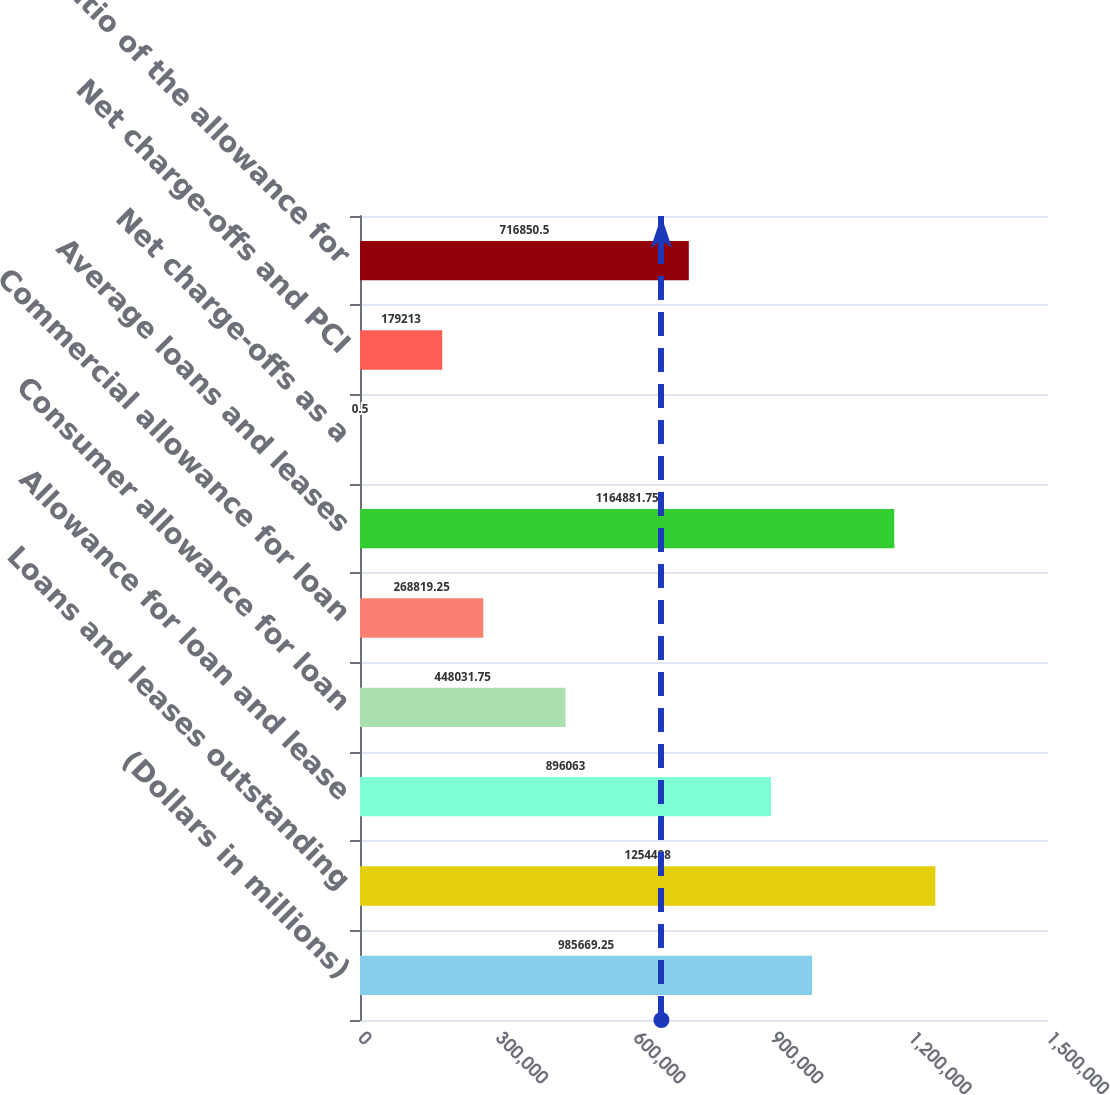Convert chart. <chart><loc_0><loc_0><loc_500><loc_500><bar_chart><fcel>(Dollars in millions)<fcel>Loans and leases outstanding<fcel>Allowance for loan and lease<fcel>Consumer allowance for loan<fcel>Commercial allowance for loan<fcel>Average loans and leases<fcel>Net charge-offs as a<fcel>Net charge-offs and PCI<fcel>Ratio of the allowance for<nl><fcel>985669<fcel>1.25449e+06<fcel>896063<fcel>448032<fcel>268819<fcel>1.16488e+06<fcel>0.5<fcel>179213<fcel>716850<nl></chart> 